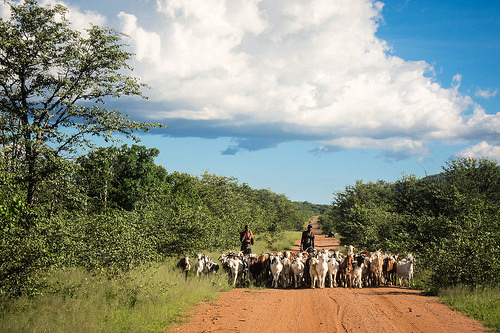<image>
Is there a tree in front of the clouds? Yes. The tree is positioned in front of the clouds, appearing closer to the camera viewpoint. 